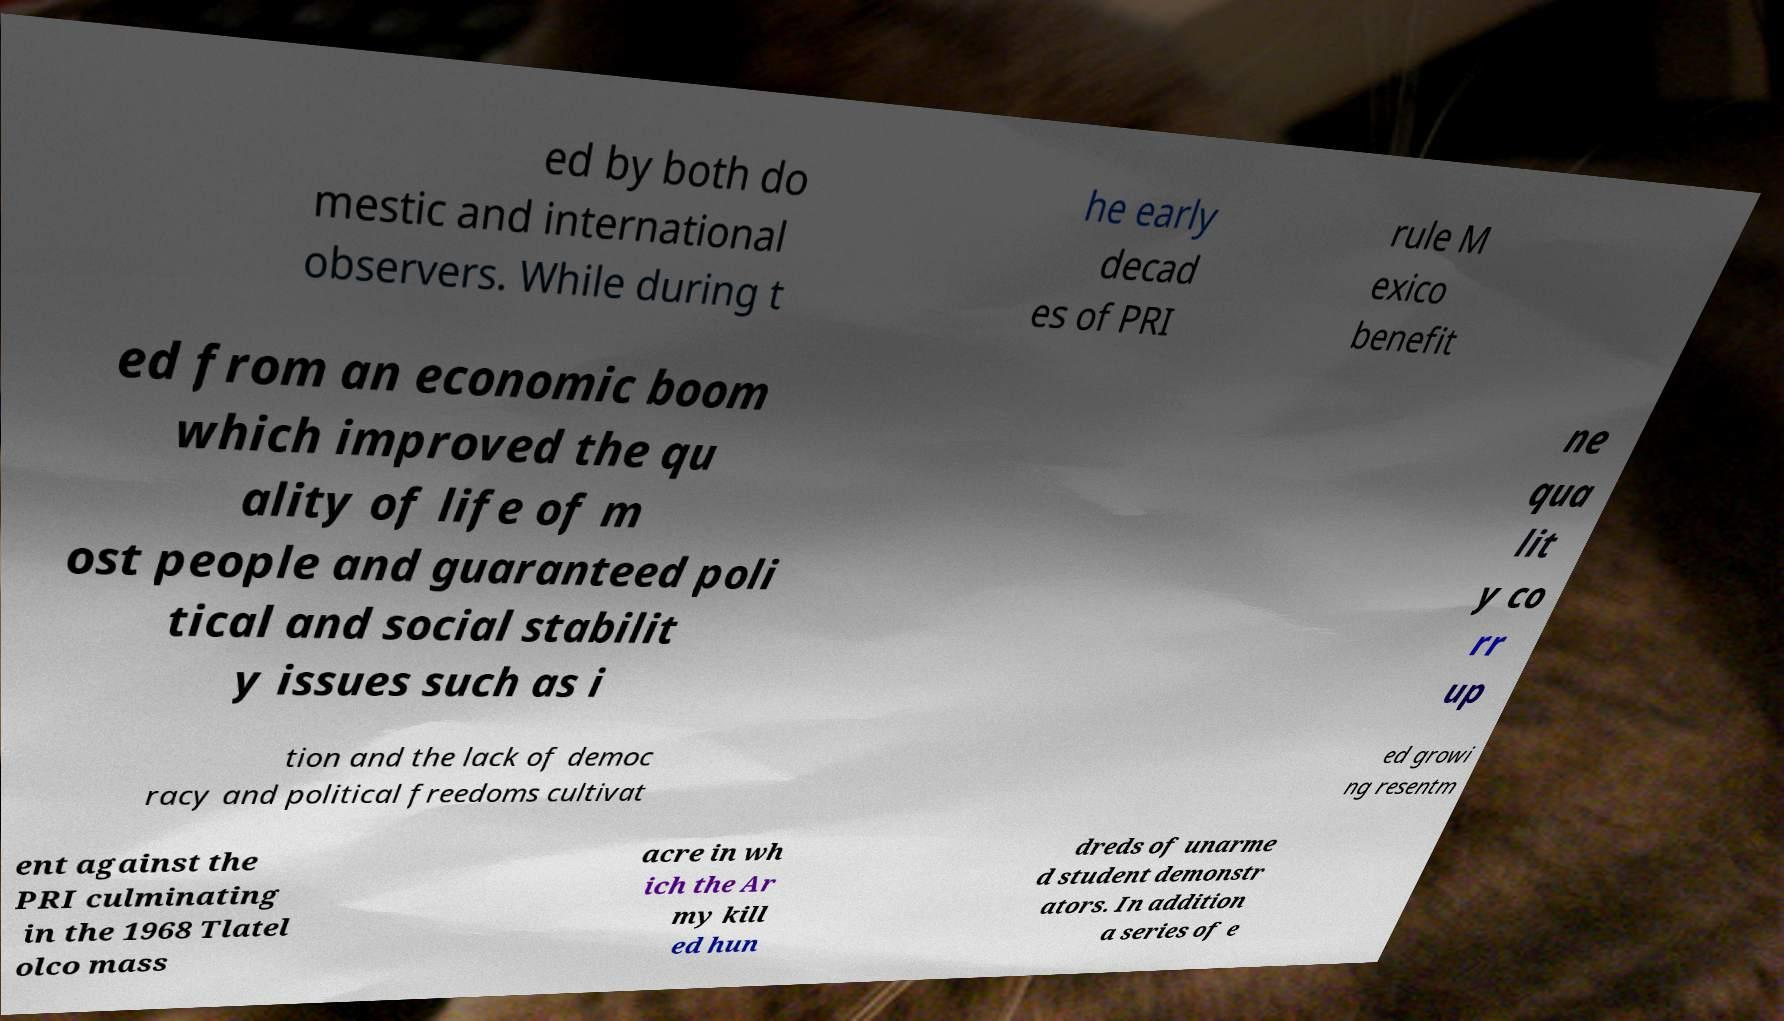Please identify and transcribe the text found in this image. ed by both do mestic and international observers. While during t he early decad es of PRI rule M exico benefit ed from an economic boom which improved the qu ality of life of m ost people and guaranteed poli tical and social stabilit y issues such as i ne qua lit y co rr up tion and the lack of democ racy and political freedoms cultivat ed growi ng resentm ent against the PRI culminating in the 1968 Tlatel olco mass acre in wh ich the Ar my kill ed hun dreds of unarme d student demonstr ators. In addition a series of e 